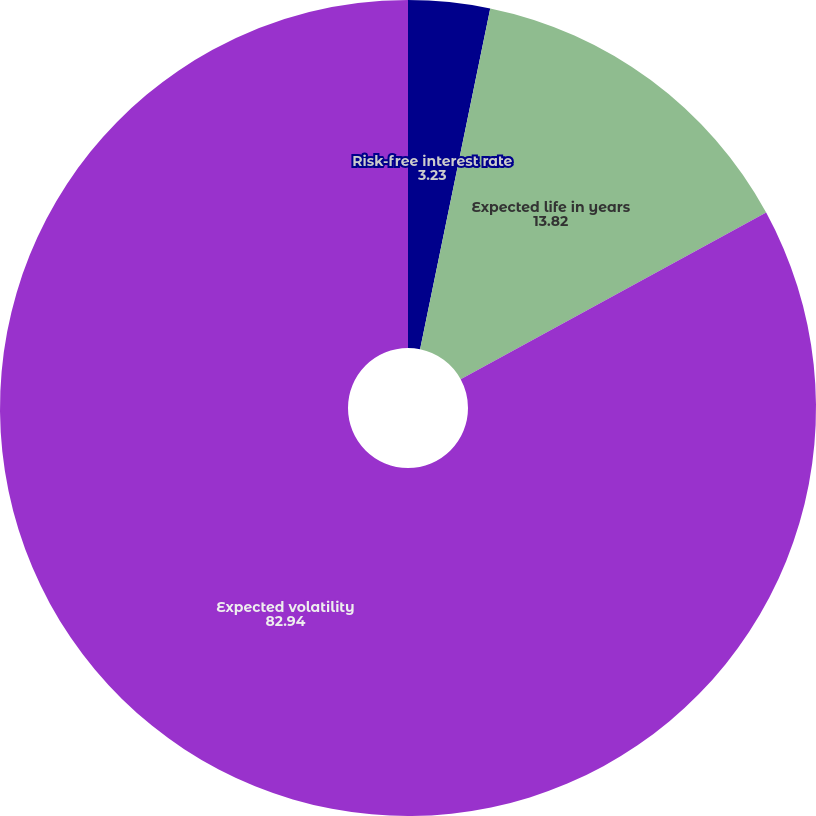Convert chart to OTSL. <chart><loc_0><loc_0><loc_500><loc_500><pie_chart><fcel>Risk-free interest rate<fcel>Expected life in years<fcel>Expected volatility<nl><fcel>3.23%<fcel>13.82%<fcel>82.94%<nl></chart> 